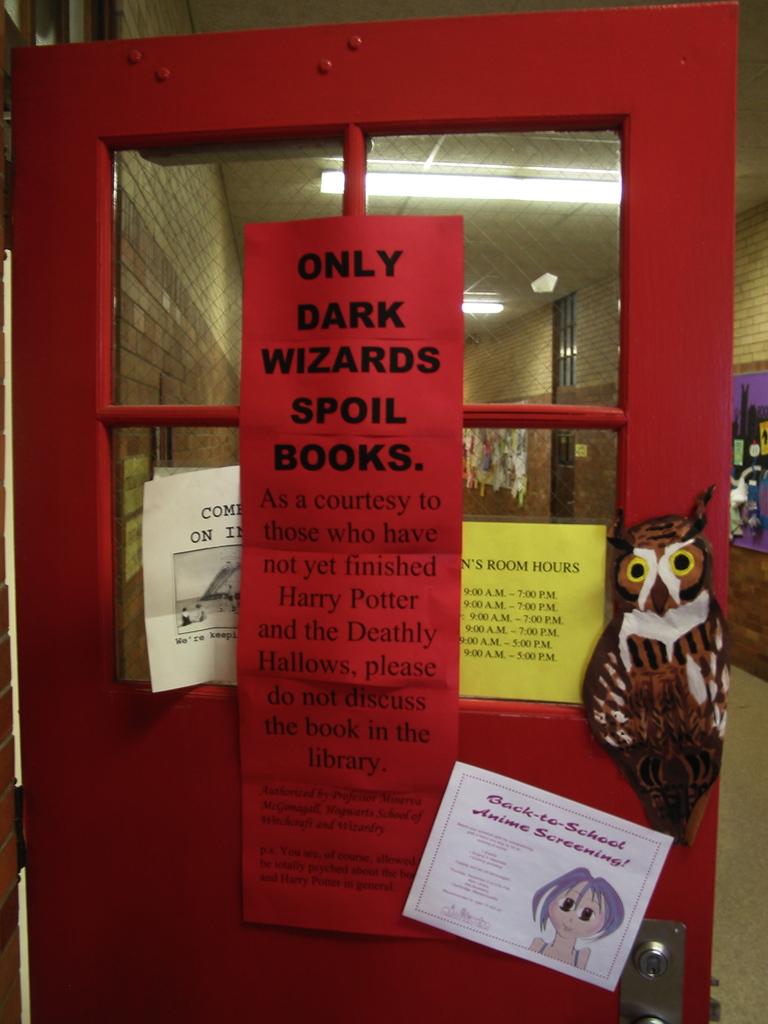What spoils books?
Offer a terse response. Dark wizards. What do the wizards spoil?
Offer a terse response. Books. 